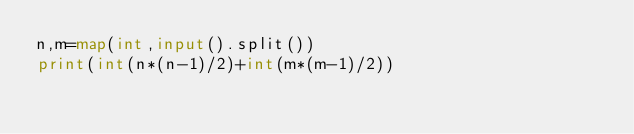Convert code to text. <code><loc_0><loc_0><loc_500><loc_500><_Python_>n,m=map(int,input().split())
print(int(n*(n-1)/2)+int(m*(m-1)/2))
</code> 